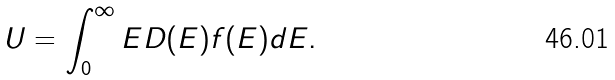<formula> <loc_0><loc_0><loc_500><loc_500>U = \int _ { 0 } ^ { \infty } E D ( E ) f ( E ) d E .</formula> 